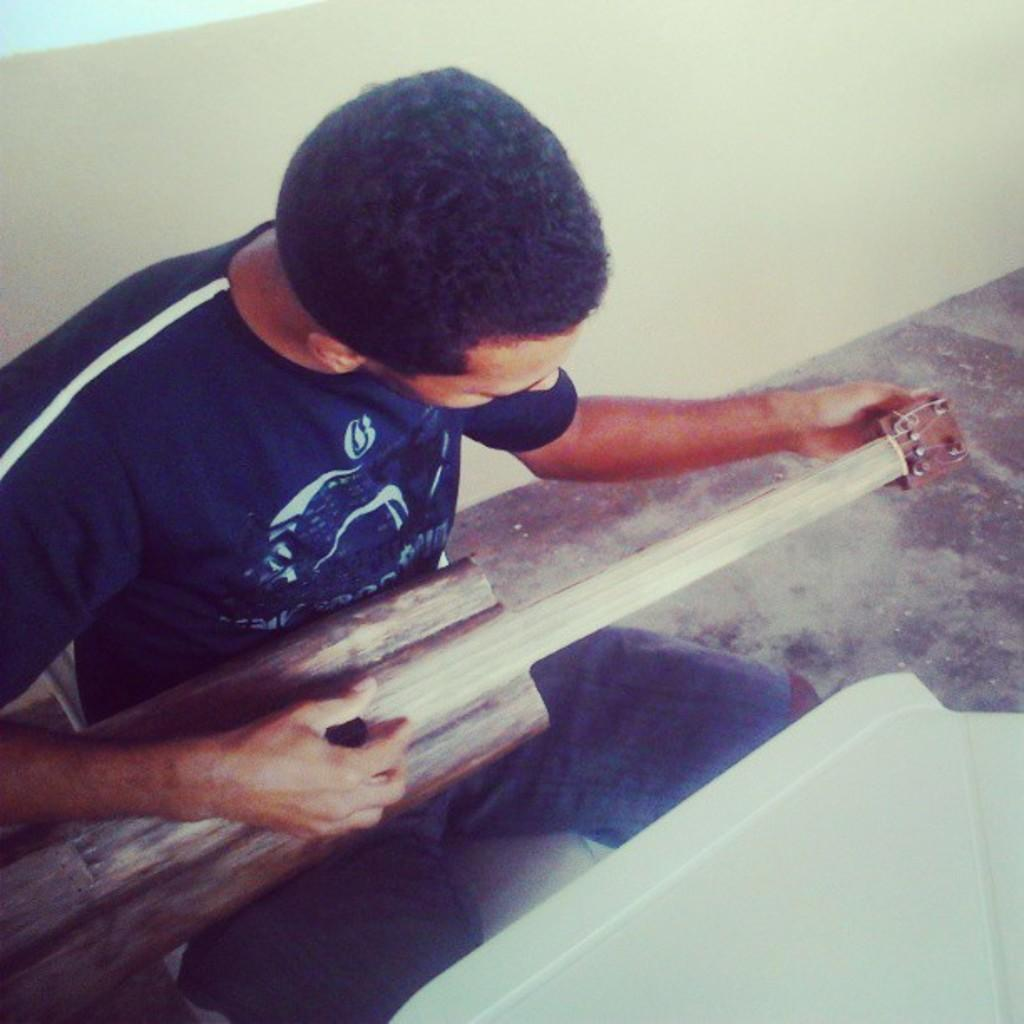What is the person in the image doing? The person is sitting in the image. What can be observed about the person's attire? The person is wearing clothes. What object is the person holding in their hands? The person is holding a musical instrument in their hands. What type of surface is visible beneath the person? There is a floor visible in the image. What architectural feature can be seen in the background? There is a wall visible in the image. What type of humor can be seen in the person's facial expression in the image? There is no indication of humor or facial expression in the image, as it only shows a person sitting and holding a musical instrument. 